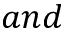Convert formula to latex. <formula><loc_0><loc_0><loc_500><loc_500>a n d</formula> 